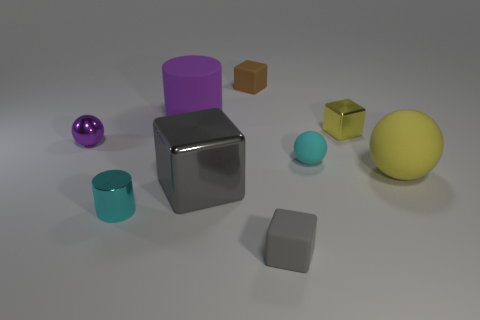Add 1 tiny cyan matte balls. How many objects exist? 10 Subtract all cylinders. How many objects are left? 7 Add 1 cubes. How many cubes are left? 5 Add 8 tiny cyan things. How many tiny cyan things exist? 10 Subtract 1 yellow spheres. How many objects are left? 8 Subtract all large yellow metallic cylinders. Subtract all big gray blocks. How many objects are left? 8 